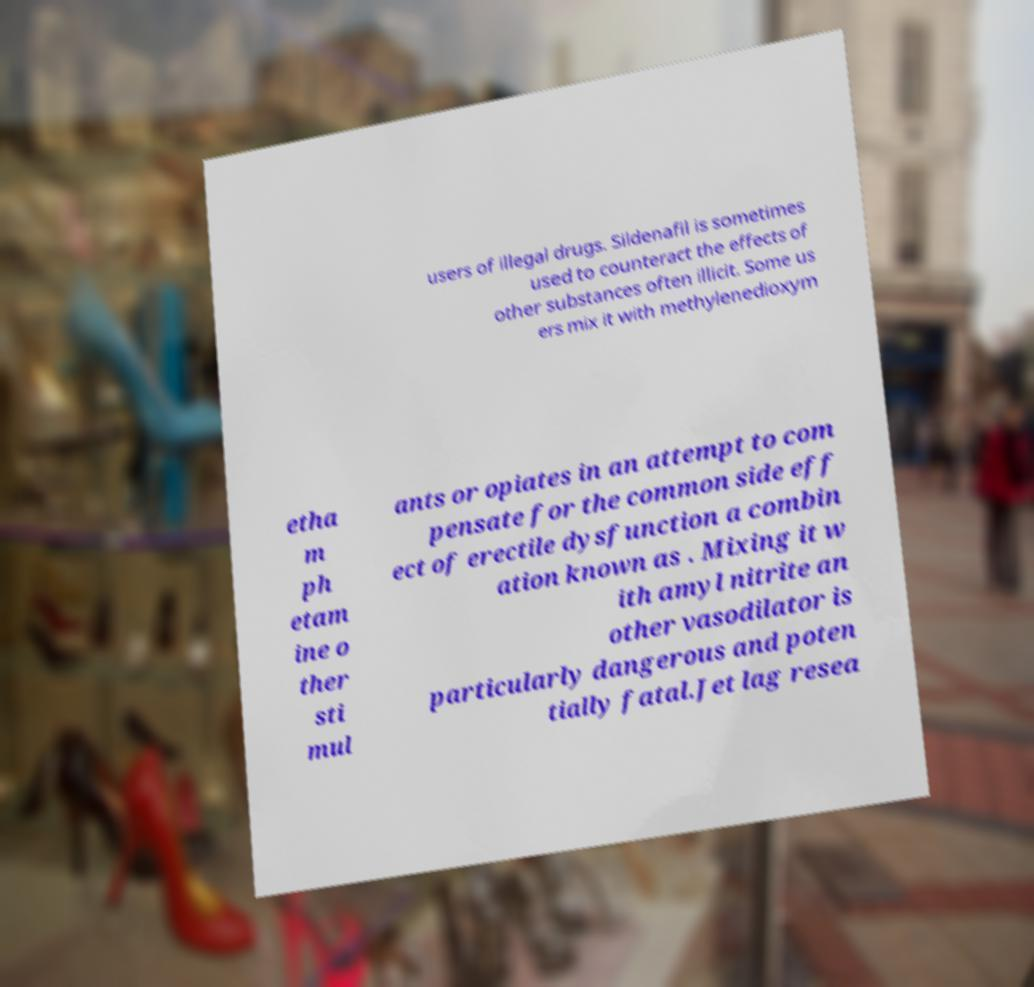Please identify and transcribe the text found in this image. users of illegal drugs. Sildenafil is sometimes used to counteract the effects of other substances often illicit. Some us ers mix it with methylenedioxym etha m ph etam ine o ther sti mul ants or opiates in an attempt to com pensate for the common side eff ect of erectile dysfunction a combin ation known as . Mixing it w ith amyl nitrite an other vasodilator is particularly dangerous and poten tially fatal.Jet lag resea 